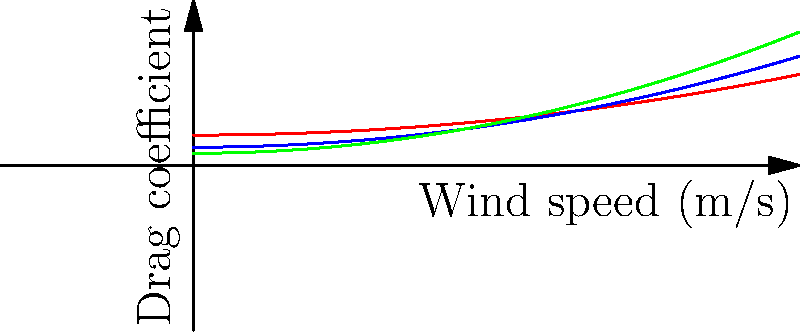Based on the wind tunnel diagram showing drag coefficient vs. wind speed for three different motorcycle fairing designs, which design would likely perform best in high-speed racing conditions? To determine which design would perform best in high-speed racing conditions, we need to analyze the drag coefficient of each design at higher wind speeds:

1. Observe the graph:
   - Red line represents Design A
   - Blue line represents Design B
   - Green line represents Design C

2. Compare drag coefficients at higher wind speeds (right side of the graph):
   - Design A has the highest drag coefficient
   - Design B has a moderate drag coefficient
   - Design C has the lowest drag coefficient at high speeds

3. Understand the impact of drag:
   - Lower drag coefficient means less air resistance
   - Less air resistance results in better performance at high speeds

4. Consider racing conditions:
   - High-speed racing requires minimizing air resistance
   - The design with the lowest drag coefficient at high speeds will perform best

5. Conclusion:
   Design C (green line) has the lowest drag coefficient at high wind speeds, making it the best choice for high-speed racing conditions.
Answer: Design C 